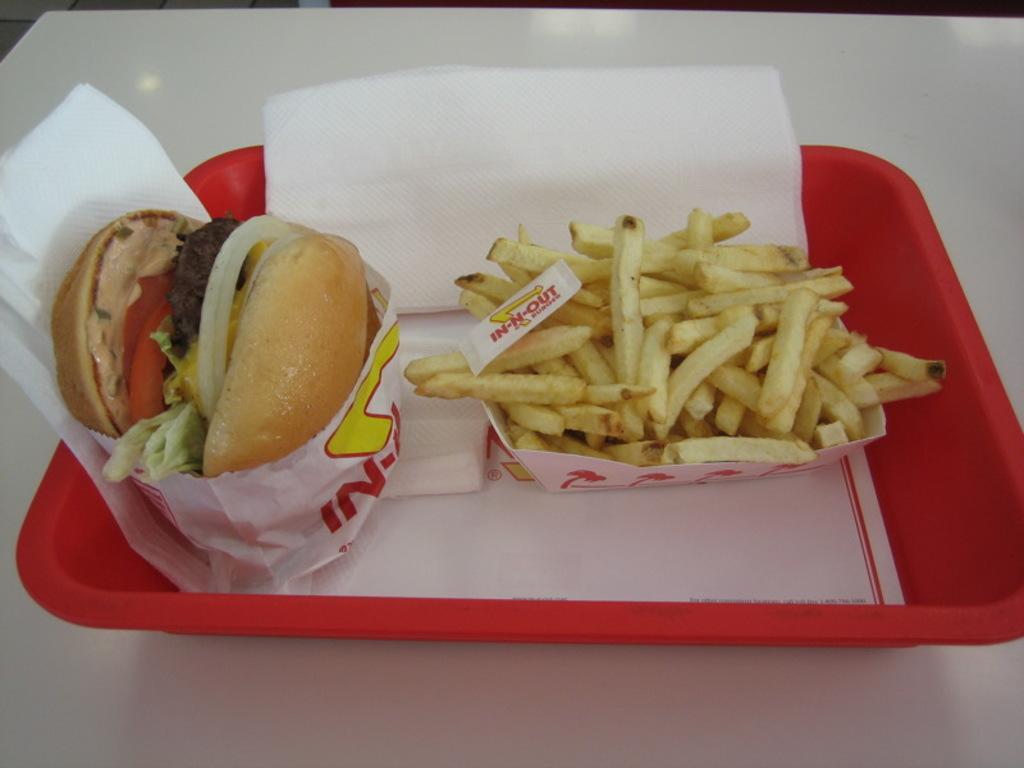In one or two sentences, can you explain what this image depicts? On a white table there is red tray which contains a burger, french fries and tissue papers. 